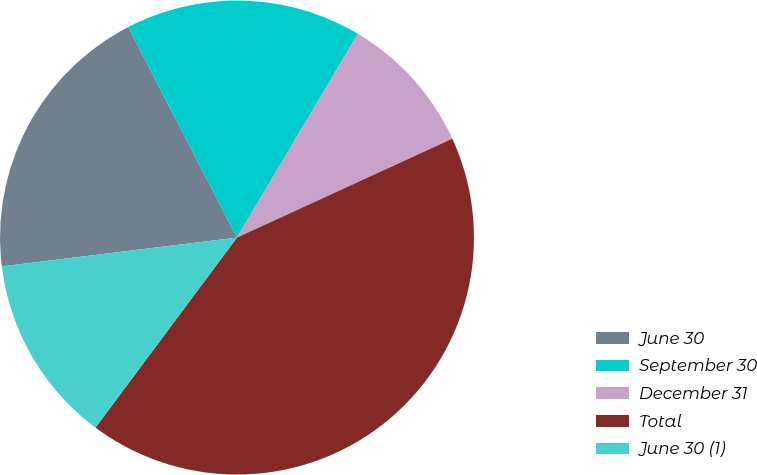Convert chart to OTSL. <chart><loc_0><loc_0><loc_500><loc_500><pie_chart><fcel>June 30<fcel>September 30<fcel>December 31<fcel>Total<fcel>June 30 (1)<nl><fcel>19.35%<fcel>16.11%<fcel>9.63%<fcel>42.04%<fcel>12.87%<nl></chart> 